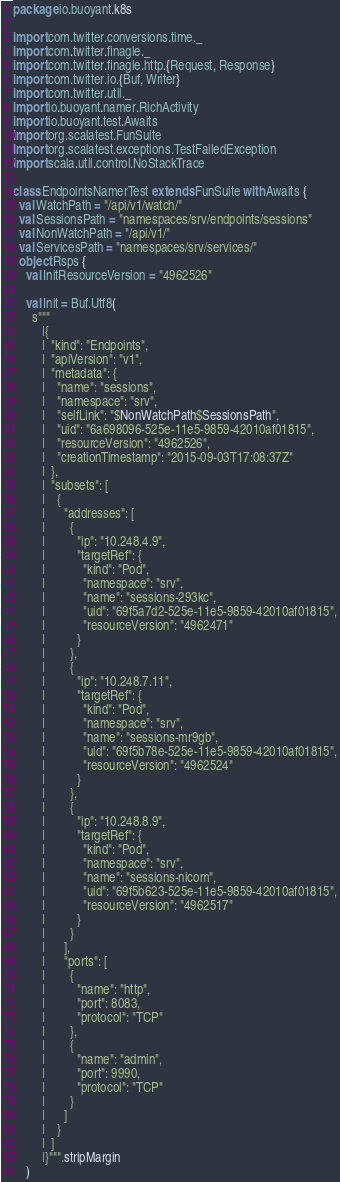Convert code to text. <code><loc_0><loc_0><loc_500><loc_500><_Scala_>package io.buoyant.k8s

import com.twitter.conversions.time._
import com.twitter.finagle._
import com.twitter.finagle.http.{Request, Response}
import com.twitter.io.{Buf, Writer}
import com.twitter.util._
import io.buoyant.namer.RichActivity
import io.buoyant.test.Awaits
import org.scalatest.FunSuite
import org.scalatest.exceptions.TestFailedException
import scala.util.control.NoStackTrace

class EndpointsNamerTest extends FunSuite with Awaits {
  val WatchPath = "/api/v1/watch/"
  val SessionsPath = "namespaces/srv/endpoints/sessions"
  val NonWatchPath = "/api/v1/"
  val ServicesPath = "namespaces/srv/services/"
  object Rsps {
    val InitResourceVersion = "4962526"

    val Init = Buf.Utf8(
      s"""
         |{
         |  "kind": "Endpoints",
         |  "apiVersion": "v1",
         |  "metadata": {
         |    "name": "sessions",
         |    "namespace": "srv",
         |    "selfLink": "$NonWatchPath$SessionsPath",
         |    "uid": "6a698096-525e-11e5-9859-42010af01815",
         |    "resourceVersion": "4962526",
         |    "creationTimestamp": "2015-09-03T17:08:37Z"
         |  },
         |  "subsets": [
         |    {
         |      "addresses": [
         |        {
         |          "ip": "10.248.4.9",
         |          "targetRef": {
         |            "kind": "Pod",
         |            "namespace": "srv",
         |            "name": "sessions-293kc",
         |            "uid": "69f5a7d2-525e-11e5-9859-42010af01815",
         |            "resourceVersion": "4962471"
         |          }
         |        },
         |        {
         |          "ip": "10.248.7.11",
         |          "targetRef": {
         |            "kind": "Pod",
         |            "namespace": "srv",
         |            "name": "sessions-mr9gb",
         |            "uid": "69f5b78e-525e-11e5-9859-42010af01815",
         |            "resourceVersion": "4962524"
         |          }
         |        },
         |        {
         |          "ip": "10.248.8.9",
         |          "targetRef": {
         |            "kind": "Pod",
         |            "namespace": "srv",
         |            "name": "sessions-nicom",
         |            "uid": "69f5b623-525e-11e5-9859-42010af01815",
         |            "resourceVersion": "4962517"
         |          }
         |        }
         |      ],
         |      "ports": [
         |        {
         |          "name": "http",
         |          "port": 8083,
         |          "protocol": "TCP"
         |        },
         |        {
         |          "name": "admin",
         |          "port": 9990,
         |          "protocol": "TCP"
         |        }
         |      ]
         |    }
         |  ]
         |}""".stripMargin
    )
</code> 